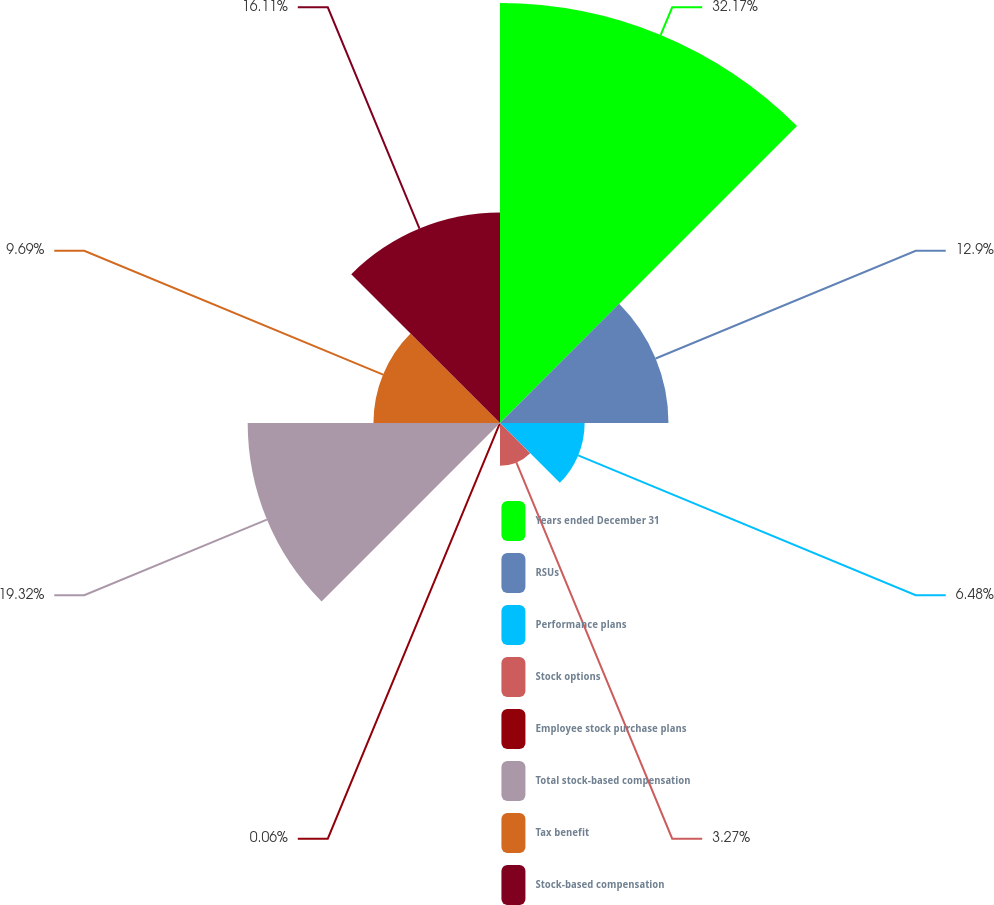<chart> <loc_0><loc_0><loc_500><loc_500><pie_chart><fcel>Years ended December 31<fcel>RSUs<fcel>Performance plans<fcel>Stock options<fcel>Employee stock purchase plans<fcel>Total stock-based compensation<fcel>Tax benefit<fcel>Stock-based compensation<nl><fcel>32.16%<fcel>12.9%<fcel>6.48%<fcel>3.27%<fcel>0.06%<fcel>19.32%<fcel>9.69%<fcel>16.11%<nl></chart> 